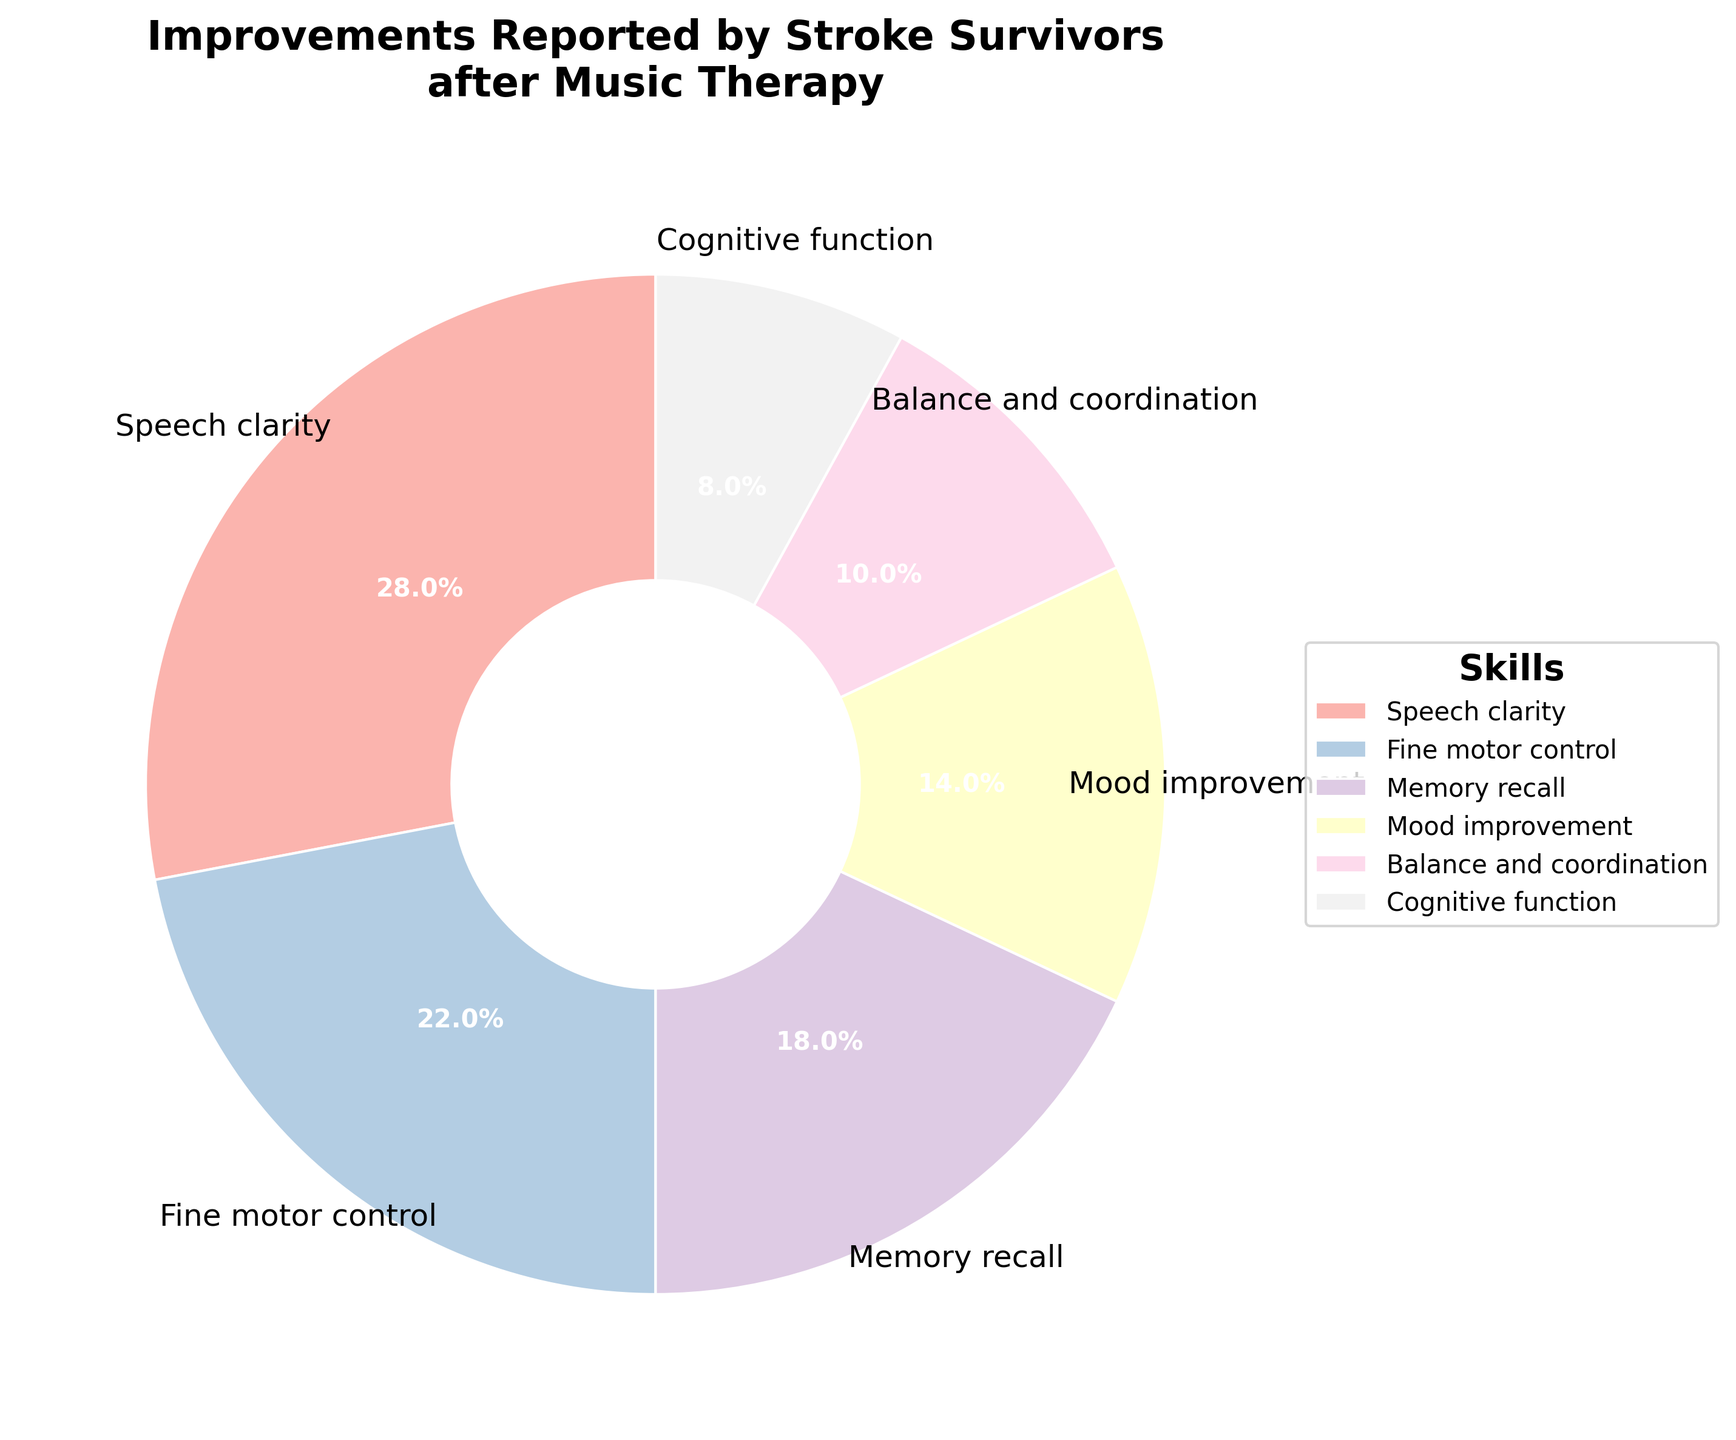What's the percentage of stroke survivors reporting improvements in speech clarity? Look at the segment labeled "Speech clarity" and note the percentage value displayed.
Answer: 28% Which skill has the second highest percentage of stroke survivors reporting improvements, and what is that percentage? Identify the skill with the highest percentage first, then find the next highest percentage and its corresponding skill from the pie chart labels.
Answer: Fine motor control, 22% Compare the total percentages of improvements reported in cognitive function and balance & coordination. Which is higher and by how much? Find the percentages for both "Cognitive function" (8%) and "Balance and coordination" (10%), then subtract the smaller value from the larger one.
Answer: Balance and coordination is higher by 2% If we combine the percentages of improvements in mood improvement and memory recall, what is their total percentage? Find the percentages for "Mood improvement" and "Memory recall," then sum these two values: 14% + 18%.
Answer: 32% What is the difference in percentage between the skill with the highest reported improvement and the skill with the lowest reported improvement? Identify the highest percentage (Speech clarity: 28%) and the lowest percentage (Cognitive function: 8%) from the pie chart, then subtract the lower from the higher.
Answer: 20% Rank the skills in order of the percentage of stroke survivors reporting improvements from highest to lowest. List the skills and their percentages, then arrange them in descending order of percentage.
Answer: Speech clarity (28%), Fine motor control (22%), Memory recall (18%), Mood improvement (14%), Balance and coordination (10%), Cognitive function (8%) What is the combined percentage of stroke survivors reporting improvements in skills related to cognition (Memory recall and Cognitive function)? Sum the percentages of "Memory recall" and "Cognitive function": 18% + 8%.
Answer: 26% Which skill improvement has the smallest segment visually on the pie chart, and what color is associated with it? Identify the smallest segment by visually comparing the sizes, then note the color of that segment.
Answer: Cognitive function, light color from Pastel1 palette Is the percentage of stroke survivors reporting improvements in fine motor control greater than the combined percentage for balance & coordination and cognitive function? Compare the percentage of fine motor control (22%) with the sum of balance & coordination (10%) and cognitive function (8%): 10% + 8% = 18%.
Answer: Yes, 22% is greater than 18% 